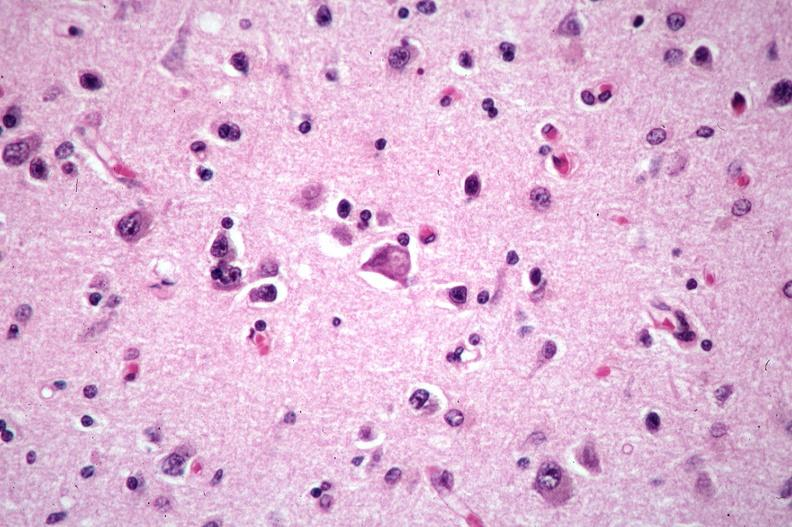where is this?
Answer the question using a single word or phrase. Nervous 